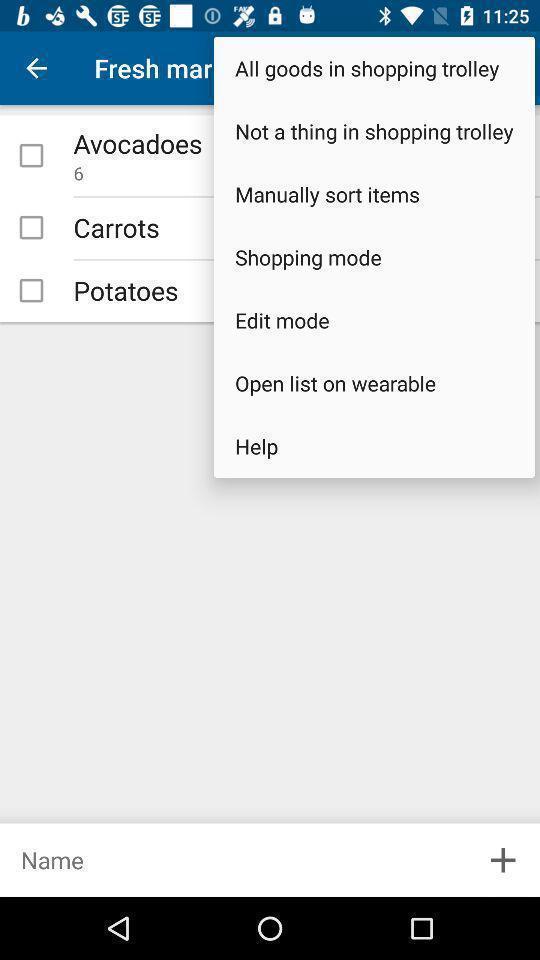Provide a detailed account of this screenshot. Pop up showing the different options. 